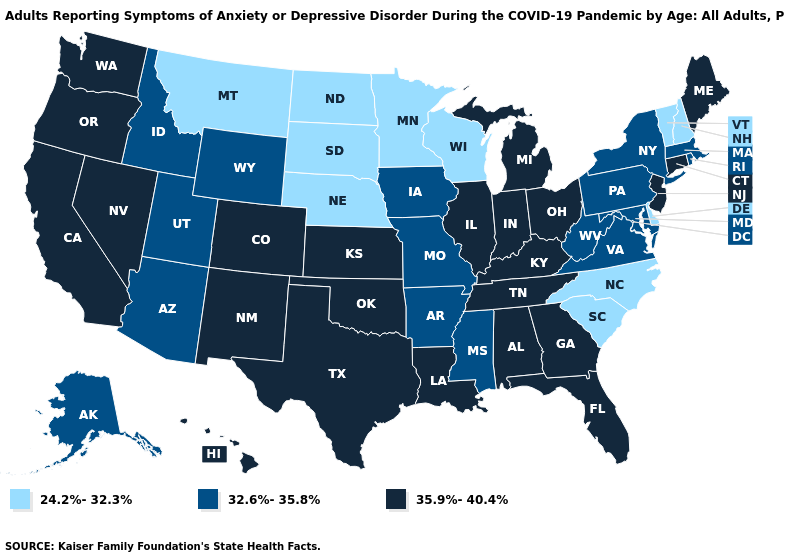What is the value of Virginia?
Short answer required. 32.6%-35.8%. Among the states that border Ohio , does Michigan have the highest value?
Give a very brief answer. Yes. Name the states that have a value in the range 32.6%-35.8%?
Quick response, please. Alaska, Arizona, Arkansas, Idaho, Iowa, Maryland, Massachusetts, Mississippi, Missouri, New York, Pennsylvania, Rhode Island, Utah, Virginia, West Virginia, Wyoming. What is the lowest value in the USA?
Concise answer only. 24.2%-32.3%. How many symbols are there in the legend?
Answer briefly. 3. What is the value of Minnesota?
Give a very brief answer. 24.2%-32.3%. Name the states that have a value in the range 24.2%-32.3%?
Answer briefly. Delaware, Minnesota, Montana, Nebraska, New Hampshire, North Carolina, North Dakota, South Carolina, South Dakota, Vermont, Wisconsin. What is the value of Pennsylvania?
Answer briefly. 32.6%-35.8%. Name the states that have a value in the range 35.9%-40.4%?
Write a very short answer. Alabama, California, Colorado, Connecticut, Florida, Georgia, Hawaii, Illinois, Indiana, Kansas, Kentucky, Louisiana, Maine, Michigan, Nevada, New Jersey, New Mexico, Ohio, Oklahoma, Oregon, Tennessee, Texas, Washington. Which states have the lowest value in the USA?
Be succinct. Delaware, Minnesota, Montana, Nebraska, New Hampshire, North Carolina, North Dakota, South Carolina, South Dakota, Vermont, Wisconsin. Does West Virginia have a higher value than Virginia?
Be succinct. No. What is the value of Connecticut?
Write a very short answer. 35.9%-40.4%. Name the states that have a value in the range 24.2%-32.3%?
Give a very brief answer. Delaware, Minnesota, Montana, Nebraska, New Hampshire, North Carolina, North Dakota, South Carolina, South Dakota, Vermont, Wisconsin. Is the legend a continuous bar?
Be succinct. No. Does Michigan have the highest value in the MidWest?
Concise answer only. Yes. 